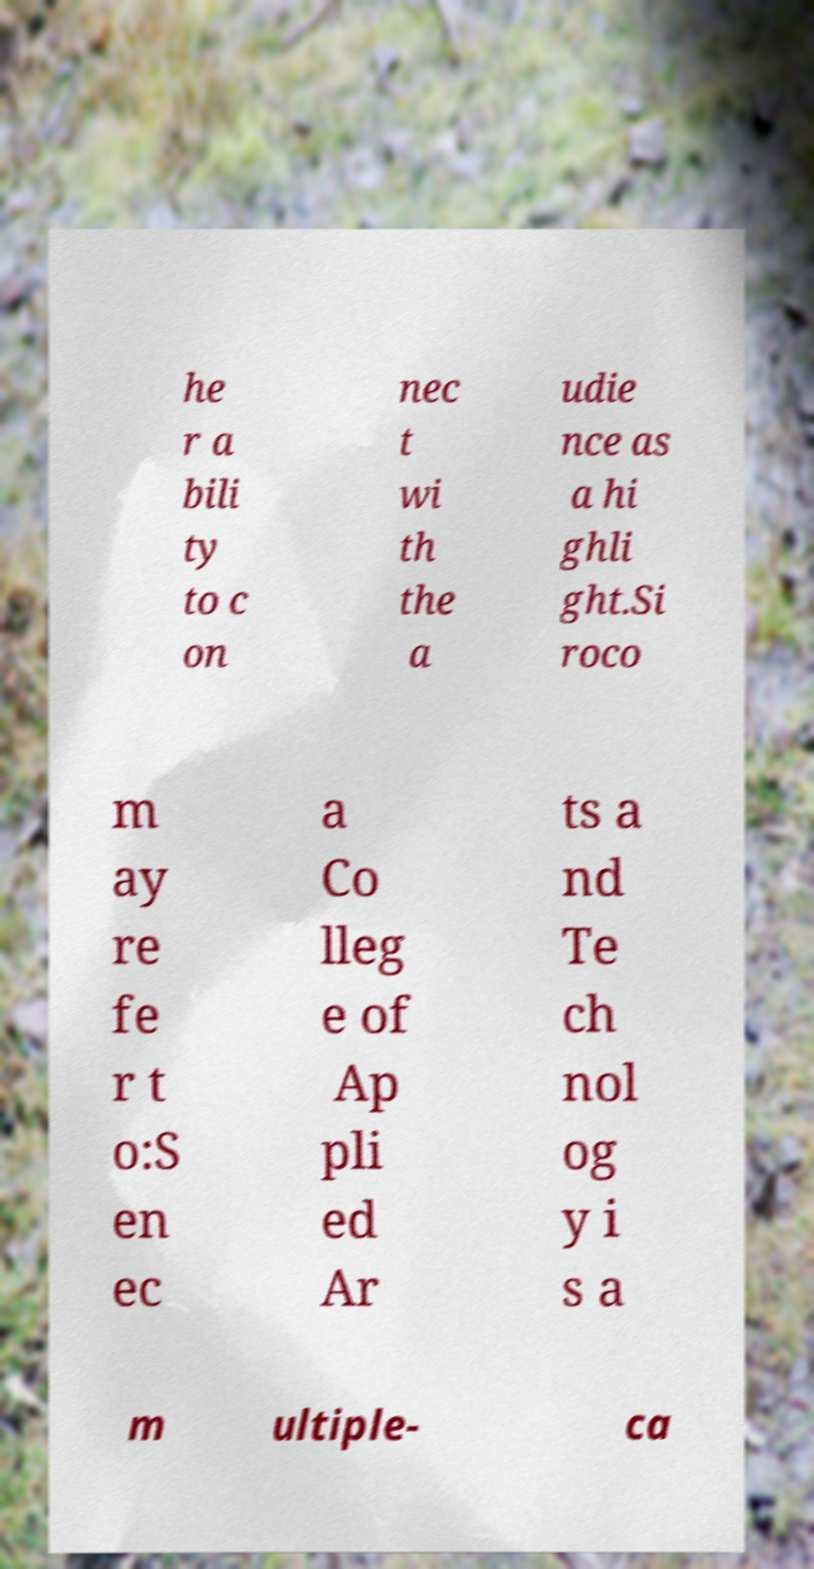I need the written content from this picture converted into text. Can you do that? he r a bili ty to c on nec t wi th the a udie nce as a hi ghli ght.Si roco m ay re fe r t o:S en ec a Co lleg e of Ap pli ed Ar ts a nd Te ch nol og y i s a m ultiple- ca 